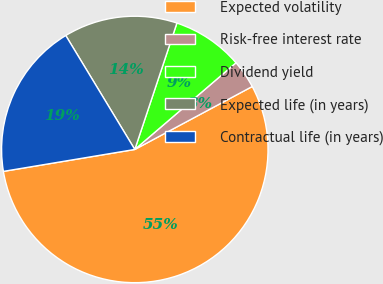Convert chart to OTSL. <chart><loc_0><loc_0><loc_500><loc_500><pie_chart><fcel>Expected volatility<fcel>Risk-free interest rate<fcel>Dividend yield<fcel>Expected life (in years)<fcel>Contractual life (in years)<nl><fcel>55.2%<fcel>3.44%<fcel>8.61%<fcel>13.79%<fcel>18.96%<nl></chart> 